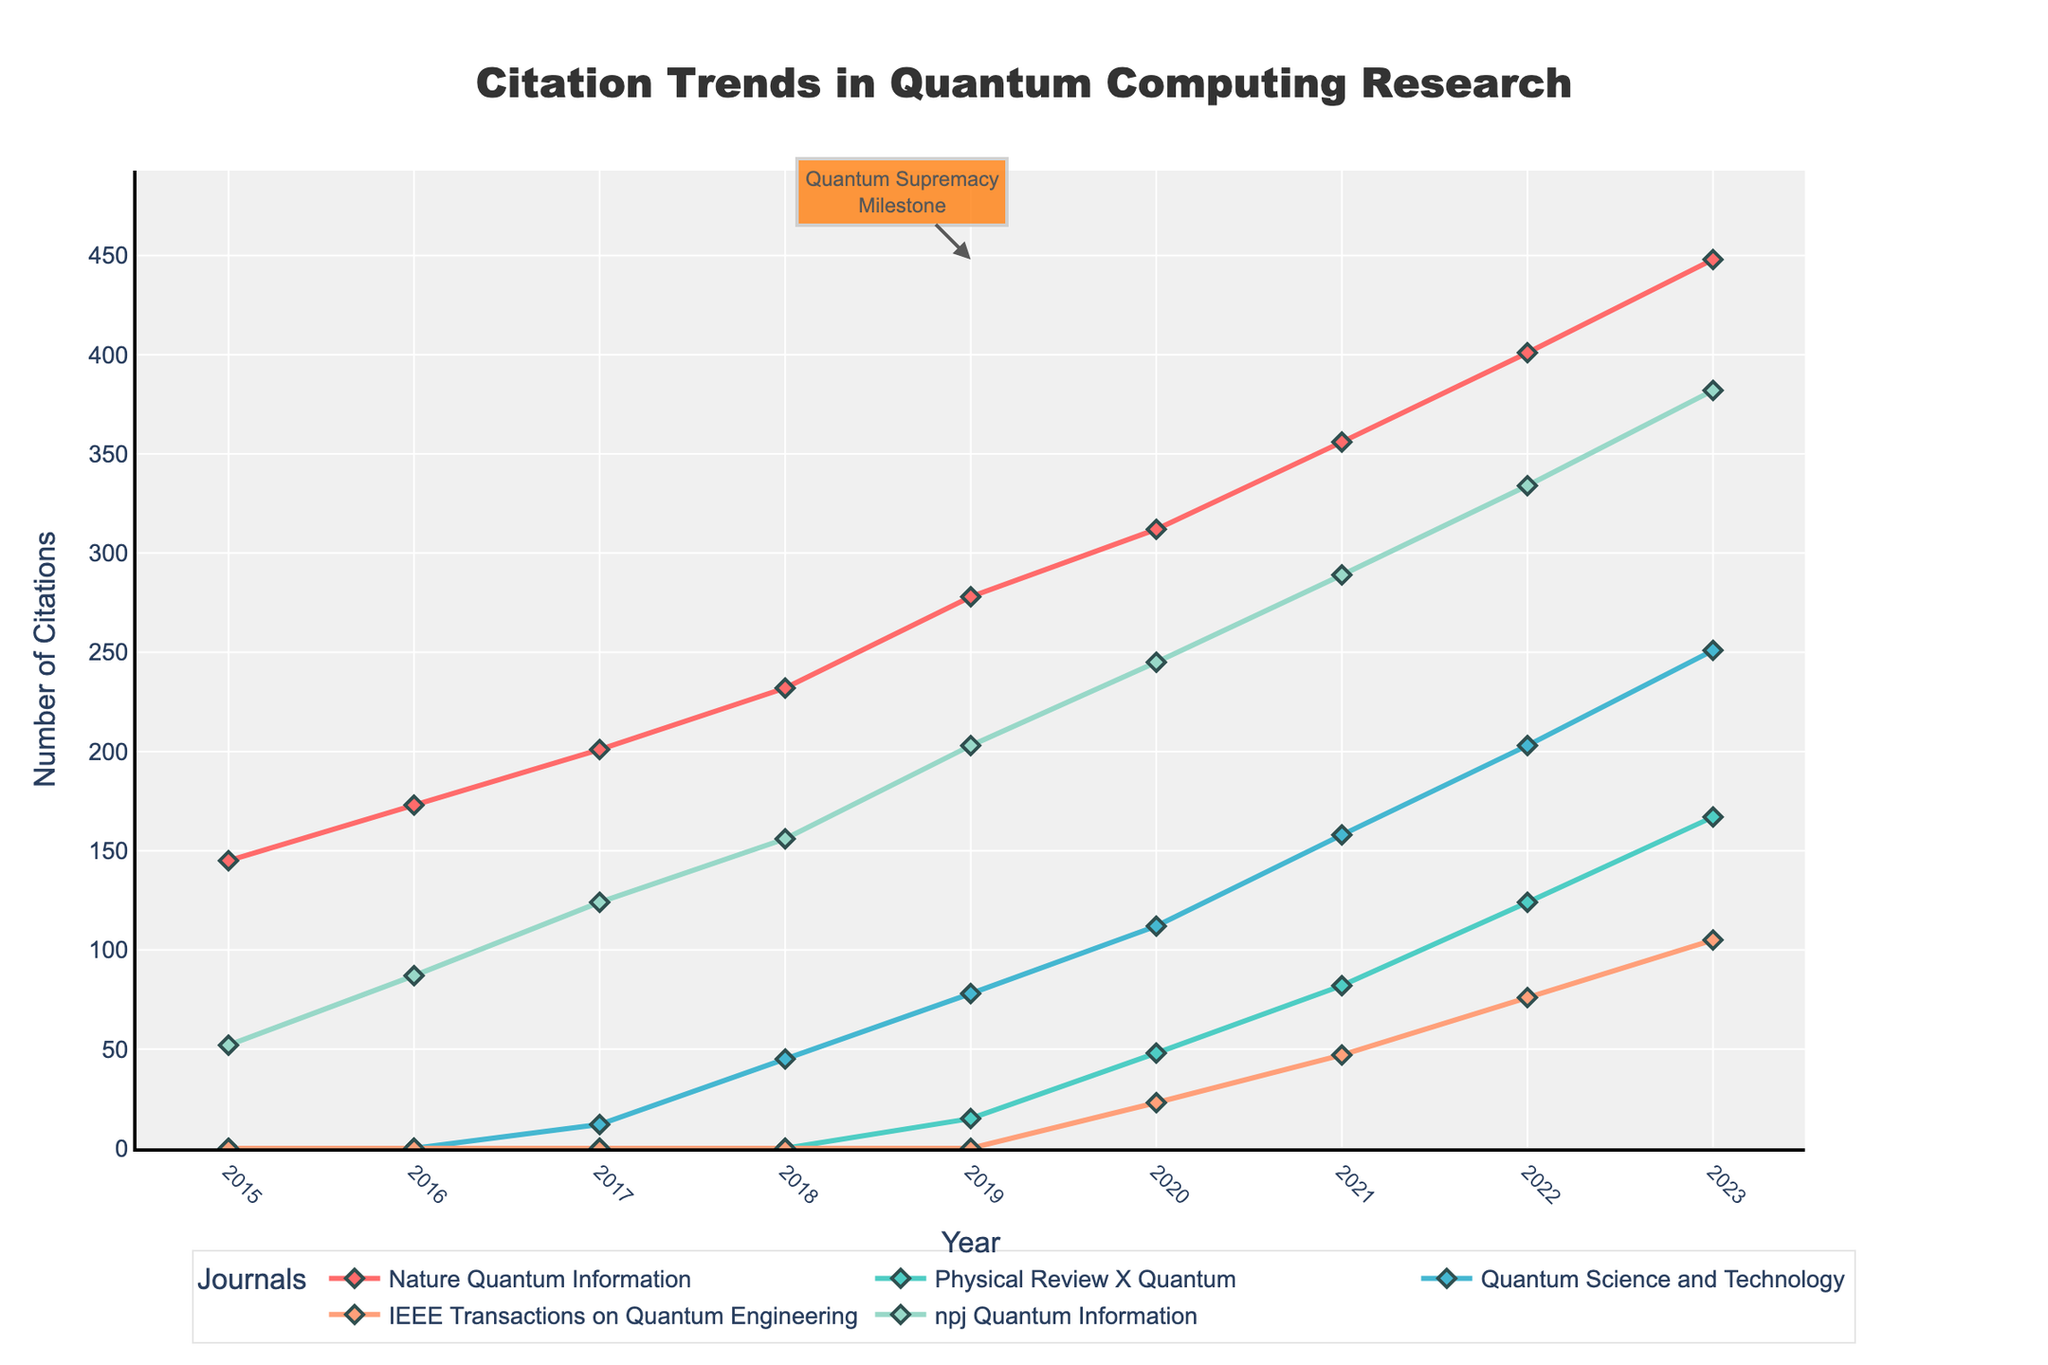What is the total number of citations for "Nature Quantum Information" in the dataset? Summing the citations for "Nature Quantum Information" from each year: 145 + 173 + 201 + 232 + 278 + 312 + 356 + 401 + 448 = 2546
Answer: 2546 In which year did "Quantum Science and Technology" first appear in the citation trend? According to the chart, "Quantum Science and Technology" citations first appear in 2017 with 12 citations.
Answer: 2017 Which journal had the most significant increase in citations from 2020 to 2023? Calculating the increase for each journal:
- Nature Quantum Information: 448 - 312 = 136
- Physical Review X Quantum: 167 - 48 = 119
- Quantum Science and Technology: 251 - 112 = 139
- IEEE Transactions on Quantum Engineering: 105 - 23 = 82
- npj Quantum Information: 382 - 245 = 137
The journal "Quantum Science and Technology" had the highest increase of 139.
Answer: Quantum Science and Technology Comparing "Nature Quantum Information" and "Physical Review X Quantum," which journal had more citations in 2021? In 2021, "Nature Quantum Information" had 356 citations, and "Physical Review X Quantum" had 82 citations. "Nature Quantum Information" had more citations.
Answer: Nature Quantum Information How many journals had over 150 citations in 2022? By examining the 2022 datapoints: "Nature Quantum Information" (401), "Physical Review X Quantum" (124), "Quantum Science and Technology" (203), "IEEE Transactions on Quantum Engineering" (76), "npj Quantum Information" (334). Three journals had over 150 citations ("Nature Quantum Information," "Quantum Science and Technology," "npj Quantum Information").
Answer: 3 Which year marked the introduction of "Physical Review X Quantum" within the citation trends? "Physical Review X Quantum" first appeared in the chart in 2019 with 15 citations.
Answer: 2019 By how much did the total citations of all journals increase from 2015 to 2023? Total citations in 2015: 145 + 0 + 0 + 0 + 52 = 197
Total citations in 2023: 448 + 167 + 251 + 105 + 382 = 1353
Increase = 1353 - 197 = 1156
Answer: 1156 What visual attribute is used to highlight the milestone annotation in the chart? The milestone annotation ("Quantum Supremacy Milestone") is highlighted by appearing with an arrow and a background color.
Answer: arrow and background color In what year did the combined citations for "ieee Transactions on Quantum Engineering" and "npj Quantum Information" first exceed 100? Adding the citations for these two journals over the years: 
- 2019: 0 + 203 = 203
The combined citations exceed 100 for the first time in 2019.
Answer: 2019 